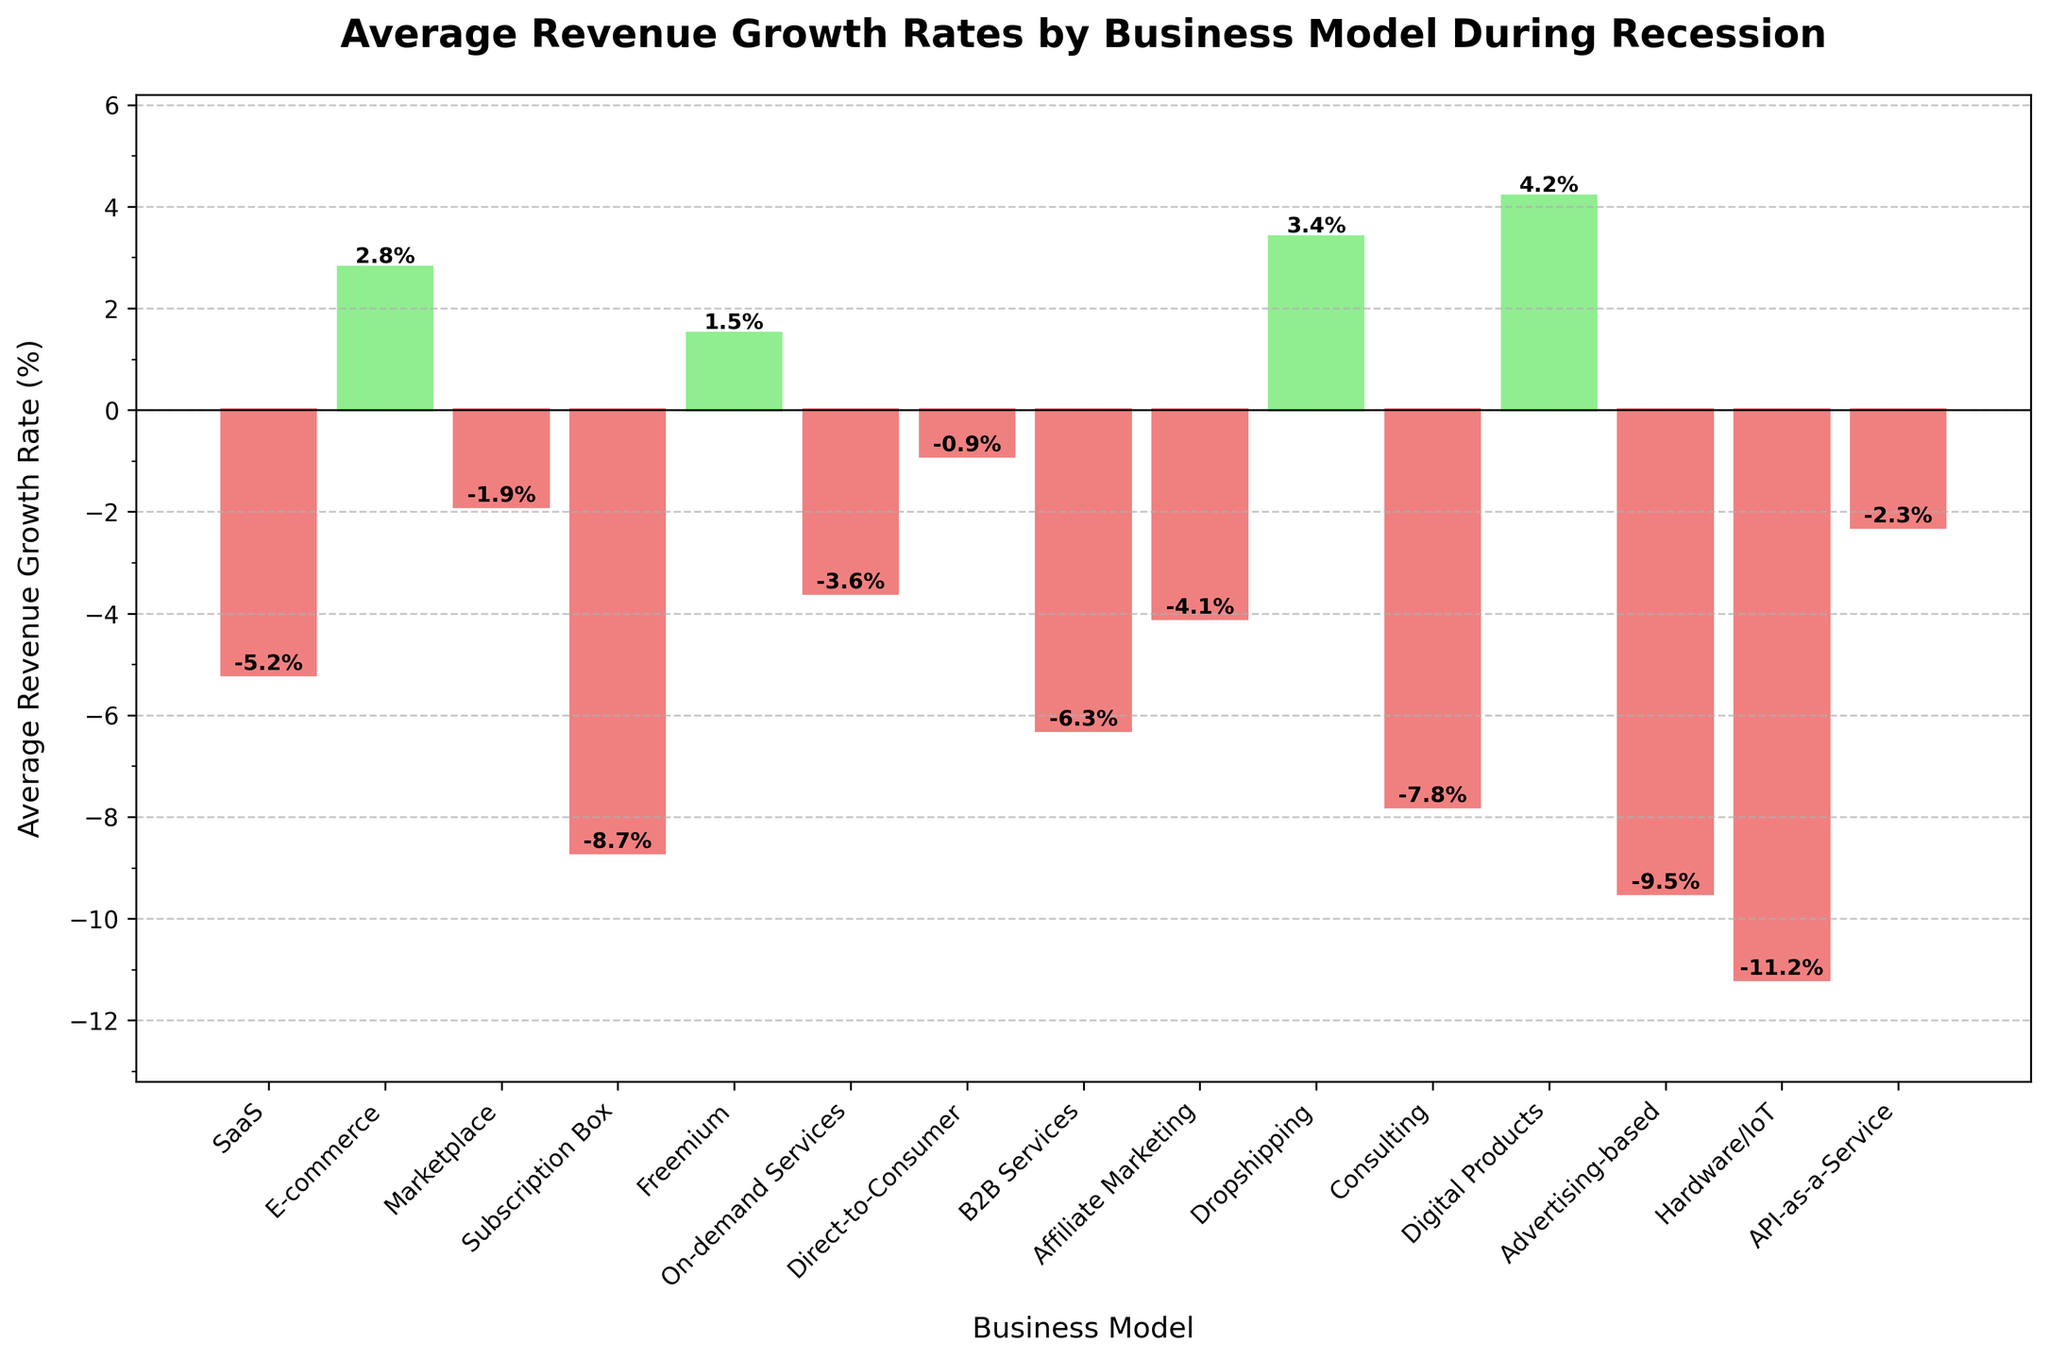Which business model has the highest average revenue growth rate during the recession? Visually, the tallest bar in the figure corresponds to the business model with the highest average revenue growth rate during the recession. Here, it is the Digital Products model with a growth rate of 4.2%.
Answer: Digital Products Which business model has the lowest average revenue growth rate during the recession? In the chart, the shortest bar (indicating the most negative value) represents the business model with the lowest average revenue growth rate. The Hardware/IoT model has the lowest growth rate at -11.2%.
Answer: Hardware/IoT What's the total revenue growth rate by combining SaaS, Marketplace, and B2B Services? To find the total revenue growth rate, sum the growth rates of the specified business models: SaaS (-5.2) + Marketplace (-1.9) + B2B Services (-6.3) = -13.4%.
Answer: -13.4% Which business models have a positive growth rate during the recession? Positive growth rates are represented by bars that extend above the y-axis (colored in light green). The business models with positive growth rates are E-commerce (2.8%), Freemium (1.5%), Dropshipping (3.4%), and Digital Products (4.2%).
Answer: E-commerce, Freemium, Dropshipping, Digital Products How much higher is the revenue growth rate of Dropshipping compared to Consulting? The growth rates of Dropshipping (3.4%) and Consulting (-7.8%) are shown in their respective bars. The difference is 3.4% - (-7.8%) = 3.4% + 7.8% = 11.2%.
Answer: 11.2% Which business model growth rate is closest to zero during the recession? The business model with growth rate closest to zero has the bar nearest the y-axis. This is the Direct-to-Consumer model with a growth rate of -0.9%.
Answer: Direct-to-Consumer Compare the growth rate of Advertising-based to the average growth rate of On-demand Services and API-as-a-Service. Advertising-based has a growth rate of -9.5%. The average growth rate of On-demand Services (-3.6%) and API-as-a-Service (-2.3%) is (-3.6 + (-2.3)) / 2 = -5.95 / 2 = -2.95%. Therefore, Advertising-based (-9.5%) is lower than -2.95%.
Answer: -9.5% is lower than -2.95% Which business models experienced a more significant decline than SaaS? Models with bars extending lower than SaaS's growth rate of -5.2% experienced a more significant decline. This includes Subscription Box (-8.7%), B2B Services (-6.3%), Affiliate Marketing (-4.1%), Consulting (-7.8%), Advertising-based (-9.5%), and Hardware/IoT (-11.2%).
Answer: Subscription Box, B2B Services, Affiliate Marketing, Consulting, Advertising-based, Hardware/IoT Is there a business model with an average revenue growth rate exactly at zero? The bars in the chart show none are at the zero mark, meaning no business model has an average revenue growth rate of exactly zero during the recession.
Answer: No What is the combined average revenue growth rate for business models with positive growth rates? Sum the growth rates of E-commerce (2.8%), Freemium (1.5%), Dropshipping (3.4%), and Digital Products (4.2%): 2.8 + 1.5 + 3.4 + 4.2 = 11.9%.
Answer: 11.9% 